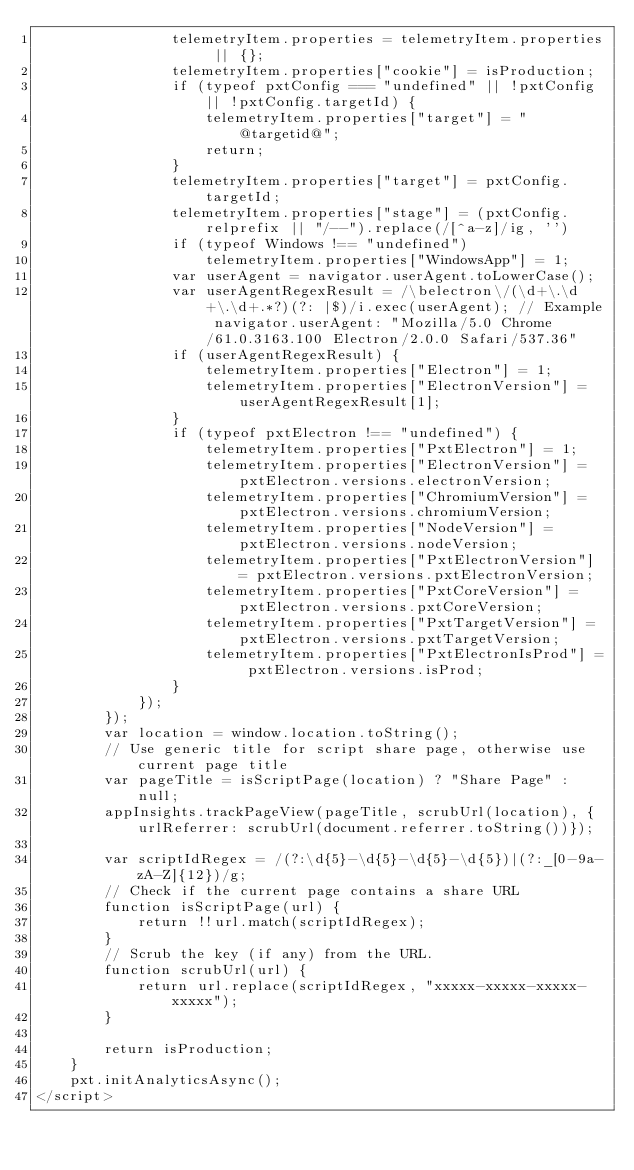Convert code to text. <code><loc_0><loc_0><loc_500><loc_500><_HTML_>                telemetryItem.properties = telemetryItem.properties || {};
                telemetryItem.properties["cookie"] = isProduction;
                if (typeof pxtConfig === "undefined" || !pxtConfig || !pxtConfig.targetId) {
                    telemetryItem.properties["target"] = "@targetid@";
                    return;
                }
                telemetryItem.properties["target"] = pxtConfig.targetId;
                telemetryItem.properties["stage"] = (pxtConfig.relprefix || "/--").replace(/[^a-z]/ig, '')
                if (typeof Windows !== "undefined")
                    telemetryItem.properties["WindowsApp"] = 1;
                var userAgent = navigator.userAgent.toLowerCase();
                var userAgentRegexResult = /\belectron\/(\d+\.\d+\.\d+.*?)(?: |$)/i.exec(userAgent); // Example navigator.userAgent: "Mozilla/5.0 Chrome/61.0.3163.100 Electron/2.0.0 Safari/537.36"
                if (userAgentRegexResult) {
                    telemetryItem.properties["Electron"] = 1;
                    telemetryItem.properties["ElectronVersion"] = userAgentRegexResult[1];
                }
                if (typeof pxtElectron !== "undefined") {
                    telemetryItem.properties["PxtElectron"] = 1;
                    telemetryItem.properties["ElectronVersion"] = pxtElectron.versions.electronVersion;
                    telemetryItem.properties["ChromiumVersion"] = pxtElectron.versions.chromiumVersion;
                    telemetryItem.properties["NodeVersion"] = pxtElectron.versions.nodeVersion;
                    telemetryItem.properties["PxtElectronVersion"] = pxtElectron.versions.pxtElectronVersion;
                    telemetryItem.properties["PxtCoreVersion"] = pxtElectron.versions.pxtCoreVersion;
                    telemetryItem.properties["PxtTargetVersion"] = pxtElectron.versions.pxtTargetVersion;
                    telemetryItem.properties["PxtElectronIsProd"] = pxtElectron.versions.isProd;
                }
            });
        });
        var location = window.location.toString();
        // Use generic title for script share page, otherwise use current page title
        var pageTitle = isScriptPage(location) ? "Share Page" : null;
        appInsights.trackPageView(pageTitle, scrubUrl(location), {urlReferrer: scrubUrl(document.referrer.toString())});

        var scriptIdRegex = /(?:\d{5}-\d{5}-\d{5}-\d{5})|(?:_[0-9a-zA-Z]{12})/g;
        // Check if the current page contains a share URL
        function isScriptPage(url) {
            return !!url.match(scriptIdRegex);
        }
        // Scrub the key (if any) from the URL.
        function scrubUrl(url) {
            return url.replace(scriptIdRegex, "xxxxx-xxxxx-xxxxx-xxxxx");
        }

        return isProduction;
    }
    pxt.initAnalyticsAsync();
</script>
</code> 